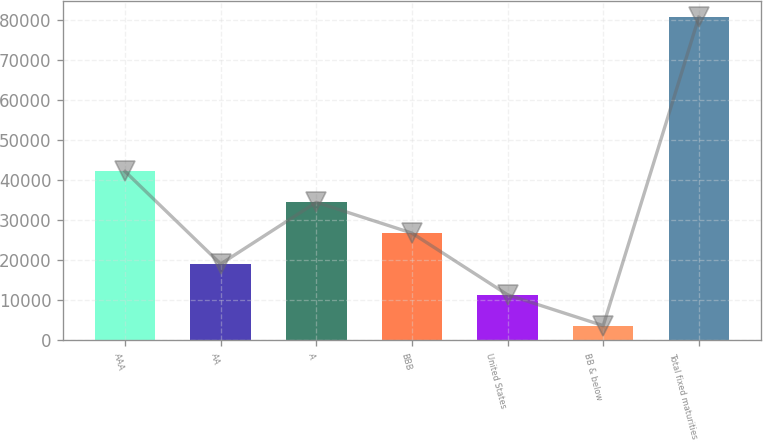Convert chart. <chart><loc_0><loc_0><loc_500><loc_500><bar_chart><fcel>AAA<fcel>AA<fcel>A<fcel>BBB<fcel>United States<fcel>BB & below<fcel>Total fixed maturities<nl><fcel>42159<fcel>19020<fcel>34446<fcel>26733<fcel>11307<fcel>3594<fcel>80724<nl></chart> 